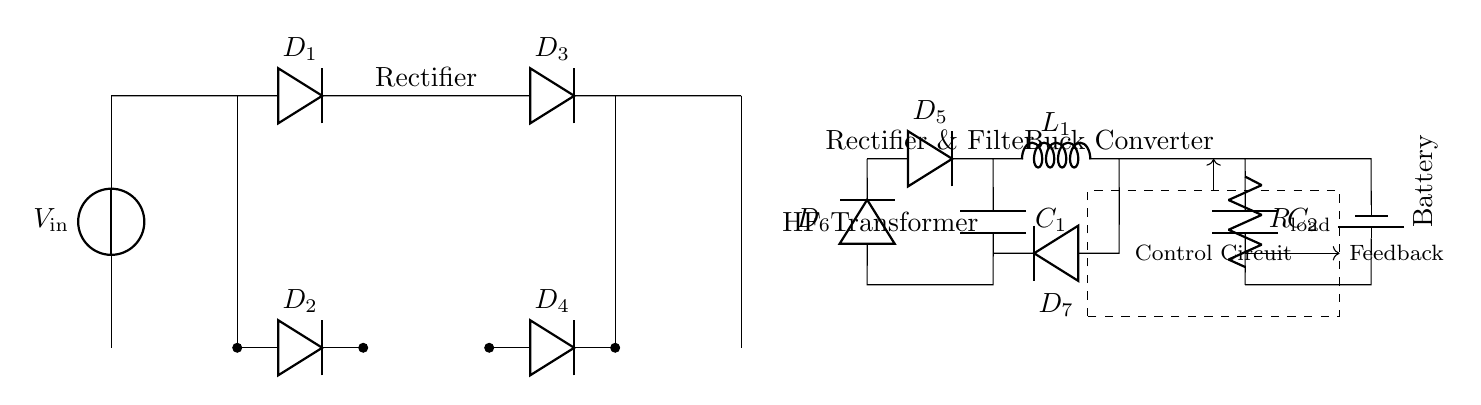What type of converter is used in this circuit? The circuit includes a buck converter, which is indicated by the label in the diagram. A buck converter is used to step down the voltage from a higher level to a lower level for efficient battery charging.
Answer: Buck converter How many diodes are present in the circuit? The circuit has six diodes labeled D1, D2, D3, D4, D5, and D6. Counting each of them provides the total number of diodes in the circuit.
Answer: Six What is the function of the transformer in this circuit? The high-frequency transformer, labeled in the diagram, is utilized for voltage transformation and isolation between the input and output stages, enhancing efficiency during charging.
Answer: Voltage transformation What is the role of the control circuit in the schematic? The control circuit, shown within the dashed rectangle, is responsible for regulating the charging process of the battery by providing feedback to adjust the output voltage and current as needed.
Answer: Regulation Which component is responsible for filtering the output after rectification? The capacitor, labeled as C1, is used to filter the output voltage after the rectification process, smoothing out fluctuations and providing a more stable DC voltage to the next stages.
Answer: Capacitor What does the symbol next to R_load represent? The symbol next to R_load indicates a resistive load in the circuit, used to simulate the demand that the battery will experience during its charging process.
Answer: Resistive load How does the circuit ensure the battery is charged efficiently? The combination of the buck converter, diodes for rectification, and the control circuit work together to step down the voltage and regulate the charging current, thus maximizing charging efficiency while protecting the battery.
Answer: Regulation and conversion 